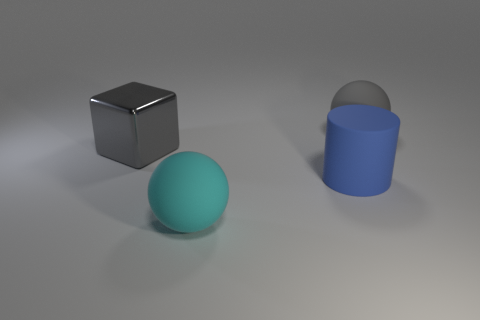What time of day does the lighting evoke in this image? The soft shadows and the cool, diffuse light could suggest an overcast day or an indoor setting with soft ambient lighting. Could there be multiple light sources? Yes, the presence of multiple shadows at varying angles indicates there might be several light sources illuminating the scene. 